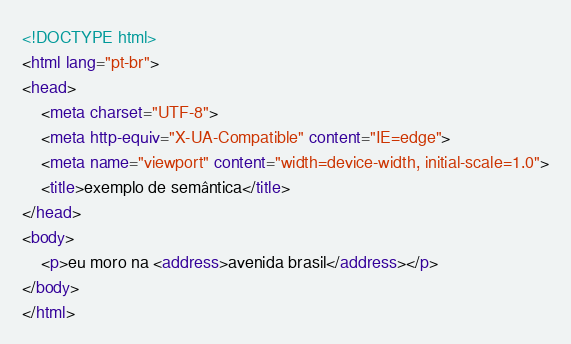Convert code to text. <code><loc_0><loc_0><loc_500><loc_500><_HTML_><!DOCTYPE html>
<html lang="pt-br">
<head>
    <meta charset="UTF-8">
    <meta http-equiv="X-UA-Compatible" content="IE=edge">
    <meta name="viewport" content="width=device-width, initial-scale=1.0">
    <title>exemplo de semântica</title>
</head>
<body>
    <p>eu moro na <address>avenida brasil</address></p>
</body>
</html></code> 